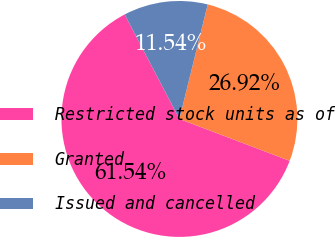<chart> <loc_0><loc_0><loc_500><loc_500><pie_chart><fcel>Restricted stock units as of<fcel>Granted<fcel>Issued and cancelled<nl><fcel>61.54%<fcel>26.92%<fcel>11.54%<nl></chart> 